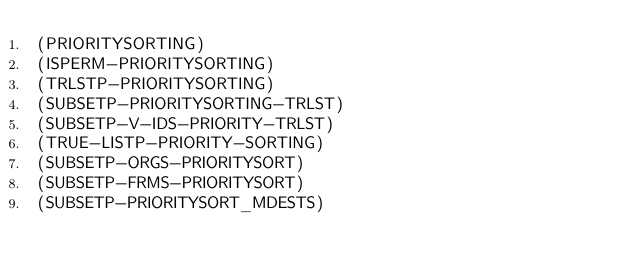Convert code to text. <code><loc_0><loc_0><loc_500><loc_500><_Lisp_>(PRIORITYSORTING)
(ISPERM-PRIORITYSORTING)
(TRLSTP-PRIORITYSORTING)
(SUBSETP-PRIORITYSORTING-TRLST)
(SUBSETP-V-IDS-PRIORITY-TRLST)
(TRUE-LISTP-PRIORITY-SORTING)
(SUBSETP-ORGS-PRIORITYSORT)
(SUBSETP-FRMS-PRIORITYSORT)
(SUBSETP-PRIORITYSORT_MDESTS)
</code> 